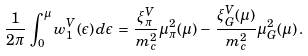Convert formula to latex. <formula><loc_0><loc_0><loc_500><loc_500>\frac { 1 } { 2 \pi } \, \int _ { 0 } ^ { \mu } w _ { 1 } ^ { V } ( \epsilon ) \, d \epsilon \, = \, \frac { \xi _ { \pi } ^ { V } } { m _ { c } ^ { 2 } } \mu _ { \pi } ^ { 2 } ( \mu ) \, - \, \frac { \xi _ { G } ^ { V } ( \mu ) } { m _ { c } ^ { 2 } } \mu _ { G } ^ { 2 } ( \mu ) \, .</formula> 